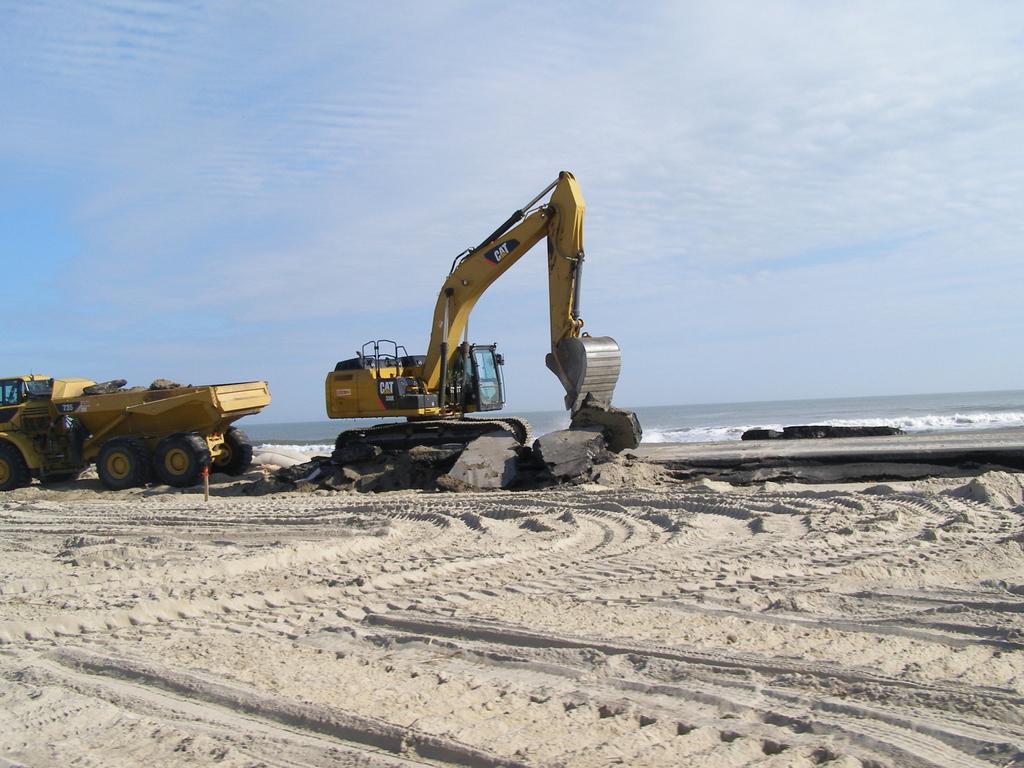Please provide a concise description of this image. In the picture we can see a sand surface on it, we can see a truck and sand, removing equipment and behind it we can see water and sky with clouds. 